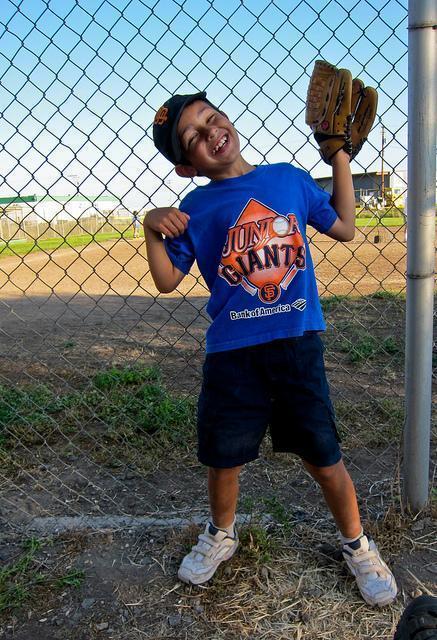What is on the boy's hand?
Make your selection from the four choices given to correctly answer the question.
Options: Glove, tattoo, caterpillar, egg yolk. Glove. 